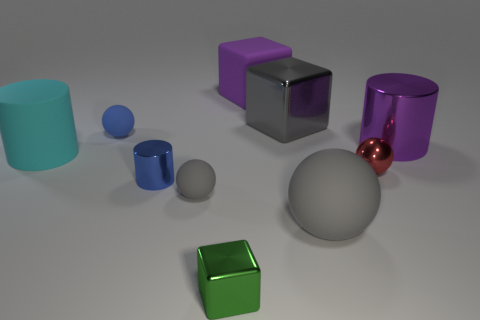What is the material of the ball behind the purple object that is right of the large gray object that is behind the purple cylinder? The ball appears to be made of a shiny material, likely metal, given its reflective surface and the way it casts highlights and shadows. This distinguishes it from materials like rubber or plastic which often have more diffuse reflections. 